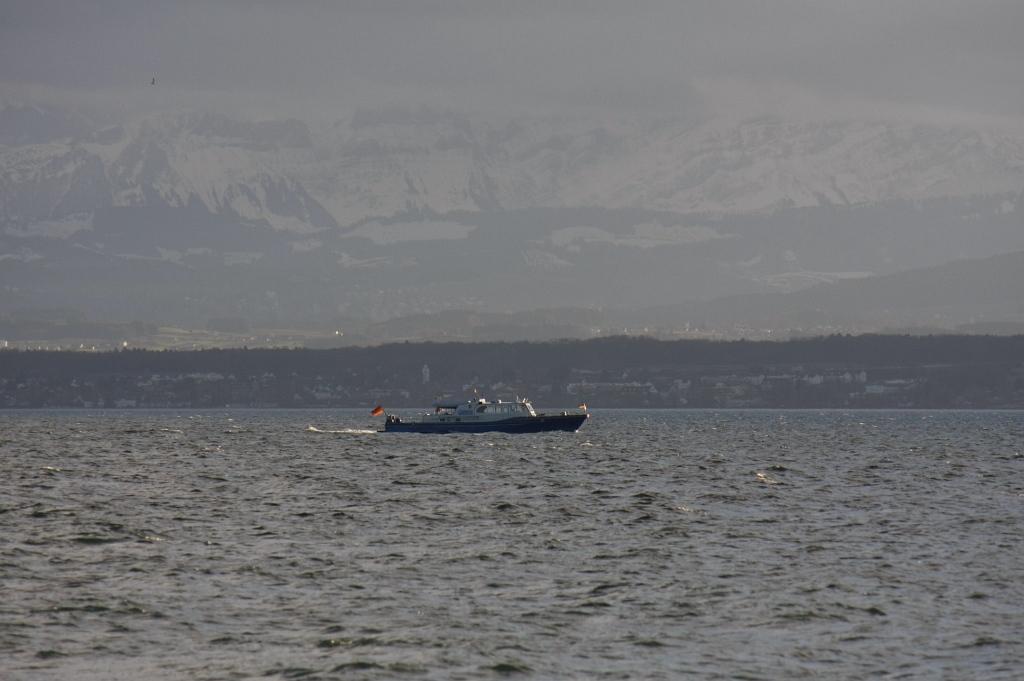Can you describe this image briefly? In this picture we can see a boat on the water. In the background we can see trees, mountains, some objects and the sky. 